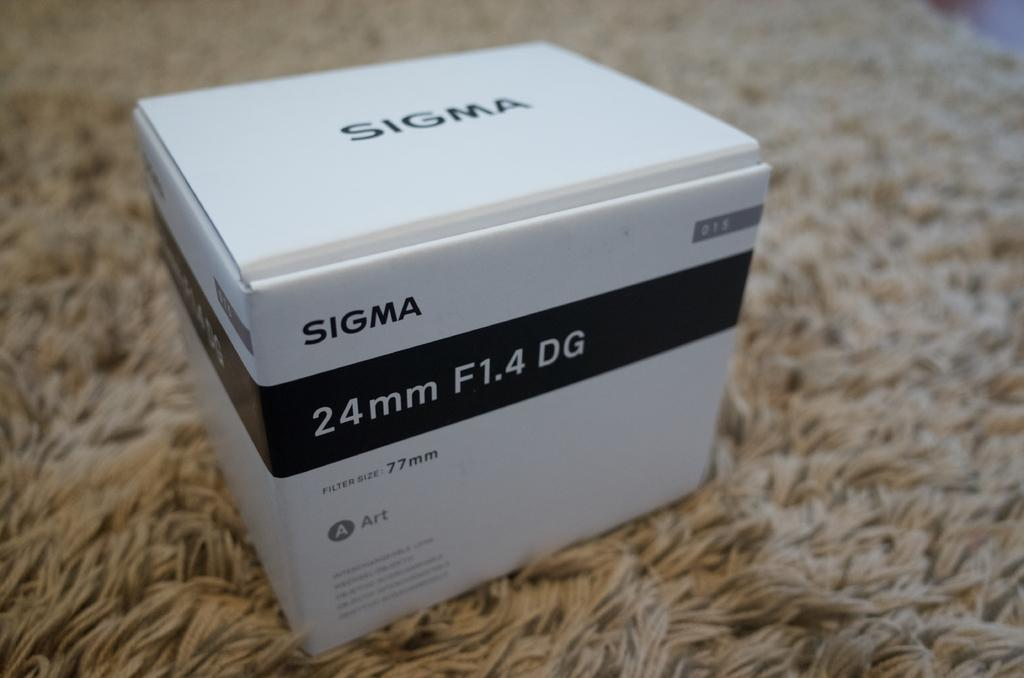<image>
Provide a brief description of the given image. A white box from Sigma sits on top of a rug. 